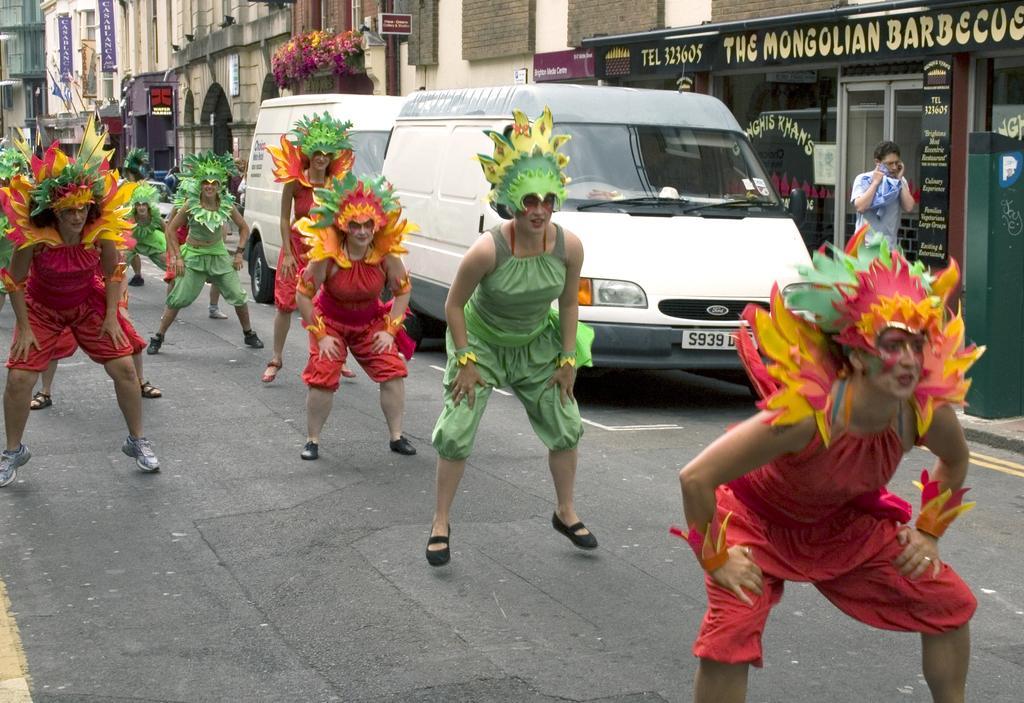How would you summarize this image in a sentence or two? In this image I can see there are few persons wearing colorful customs visible on the road , on the road there are few vehicles kept , at the top there are buildings ,on the wall of the building there is a text, person visible in front of the building there are some boards attached to the wall of the building. 